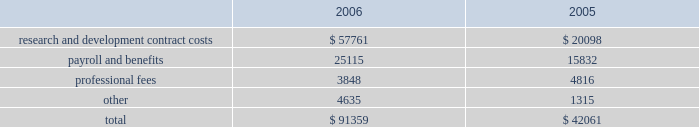Vertex pharmaceuticals incorporated notes to consolidated financial statements ( continued ) i .
Altus investment ( continued ) of the offering , held 450000 shares of redeemable preferred stock , which are not convertible into common stock and which are redeemable for $ 10.00 per share plus annual dividends of $ 0.50 per share , which have been accruing since the redeemable preferred stock was issued in 1999 , at vertex 2019s option on or after december 31 , 2010 , or by altus at any time .
The company was restricted from trading altus securities for a period of six months following the initial public offering .
When the altus securities trading restrictions expired , the company sold the 817749 shares of altus common stock for approximately $ 11.7 million , resulting in a realized gain of approximately $ 7.7 million in august 2006 .
Additionally when the restrictions expired , the company began accounting for the altus warrants as derivative instruments under the financial accounting standards board statement no .
Fas 133 , 201caccounting for derivative instruments and hedging activities 201d ( 201cfas 133 201d ) .
In accordance with fas 133 , in the third quarter of 2006 , the company recorded the altus warrants on its consolidated balance sheet at a fair market value of $ 19.1 million and recorded an unrealized gain on the fair market value of the altus warrants of $ 4.3 million .
In the fourth quarter of 2006 the company sold the altus warrants for approximately $ 18.3 million , resulting in a realized loss of $ 0.7 million .
As a result of the company 2019s sales of altus common stock and altus warrrants in 2006 , the company recorded a realized gain on a sale of investment of $ 11.2 million .
In accordance with the company 2019s policy , as outlined in note b , 201caccounting policies , 201d the company assessed its investment in altus , which it accounts for using the cost method , and determined that there had not been any adjustments to the fair values of that investment that would require the company to write down the investment basis of the asset , in 2005 and 2006 .
The company 2019s cost basis carrying value in its outstanding equity and warrants of altus was $ 18.9 million at december 31 , 2005 .
Accrued expenses and other current liabilities accrued expenses and other current liabilities consist of the following at december 31 ( in thousands ) : k .
Commitments the company leases its facilities and certain equipment under non-cancelable operating leases .
The company 2019s leases have terms through april 2018 .
The term of the kendall square lease began january 1 , 2003 and lease payments commenced in may 2003 .
The company had an obligation under the kendall square lease , staged through 2006 , to build-out the space into finished laboratory and office space .
This lease will expire in 2018 , and the company has the option to extend the term for two consecutive terms of ten years each , ultimately expiring in 2038 .
The company occupies and uses for its operations approximately 120000 square feet of the kendall square facility .
The company has sublease arrangements in place for the remaining rentable square footage of the kendall square facility , with initial terms that expires in april 2011 and august 2012 .
See note e , 201crestructuring 201d for further information. .
Research and development contract costs $ 57761 $ 20098 payroll and benefits 25115 15832 professional fees 3848 4816 4635 1315 $ 91359 $ 42061 .
In 2006 what was the percent of the recorded an unrealized gain on the fair market value of the altus warrants\\n? 
Computations: (4.3 / 19.1)
Answer: 0.22513. 